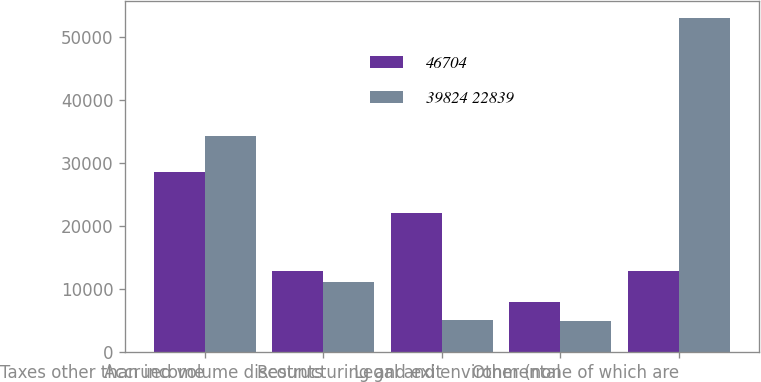Convert chart. <chart><loc_0><loc_0><loc_500><loc_500><stacked_bar_chart><ecel><fcel>Taxes other than income<fcel>Accrued volume discounts<fcel>Restructuring and exit<fcel>Legal and environmental<fcel>Other (none of which are<nl><fcel>46704<fcel>28452<fcel>12799<fcel>22021<fcel>7868<fcel>12799<nl><fcel>39824 22839<fcel>34229<fcel>11151<fcel>4986<fcel>4967<fcel>52966<nl></chart> 